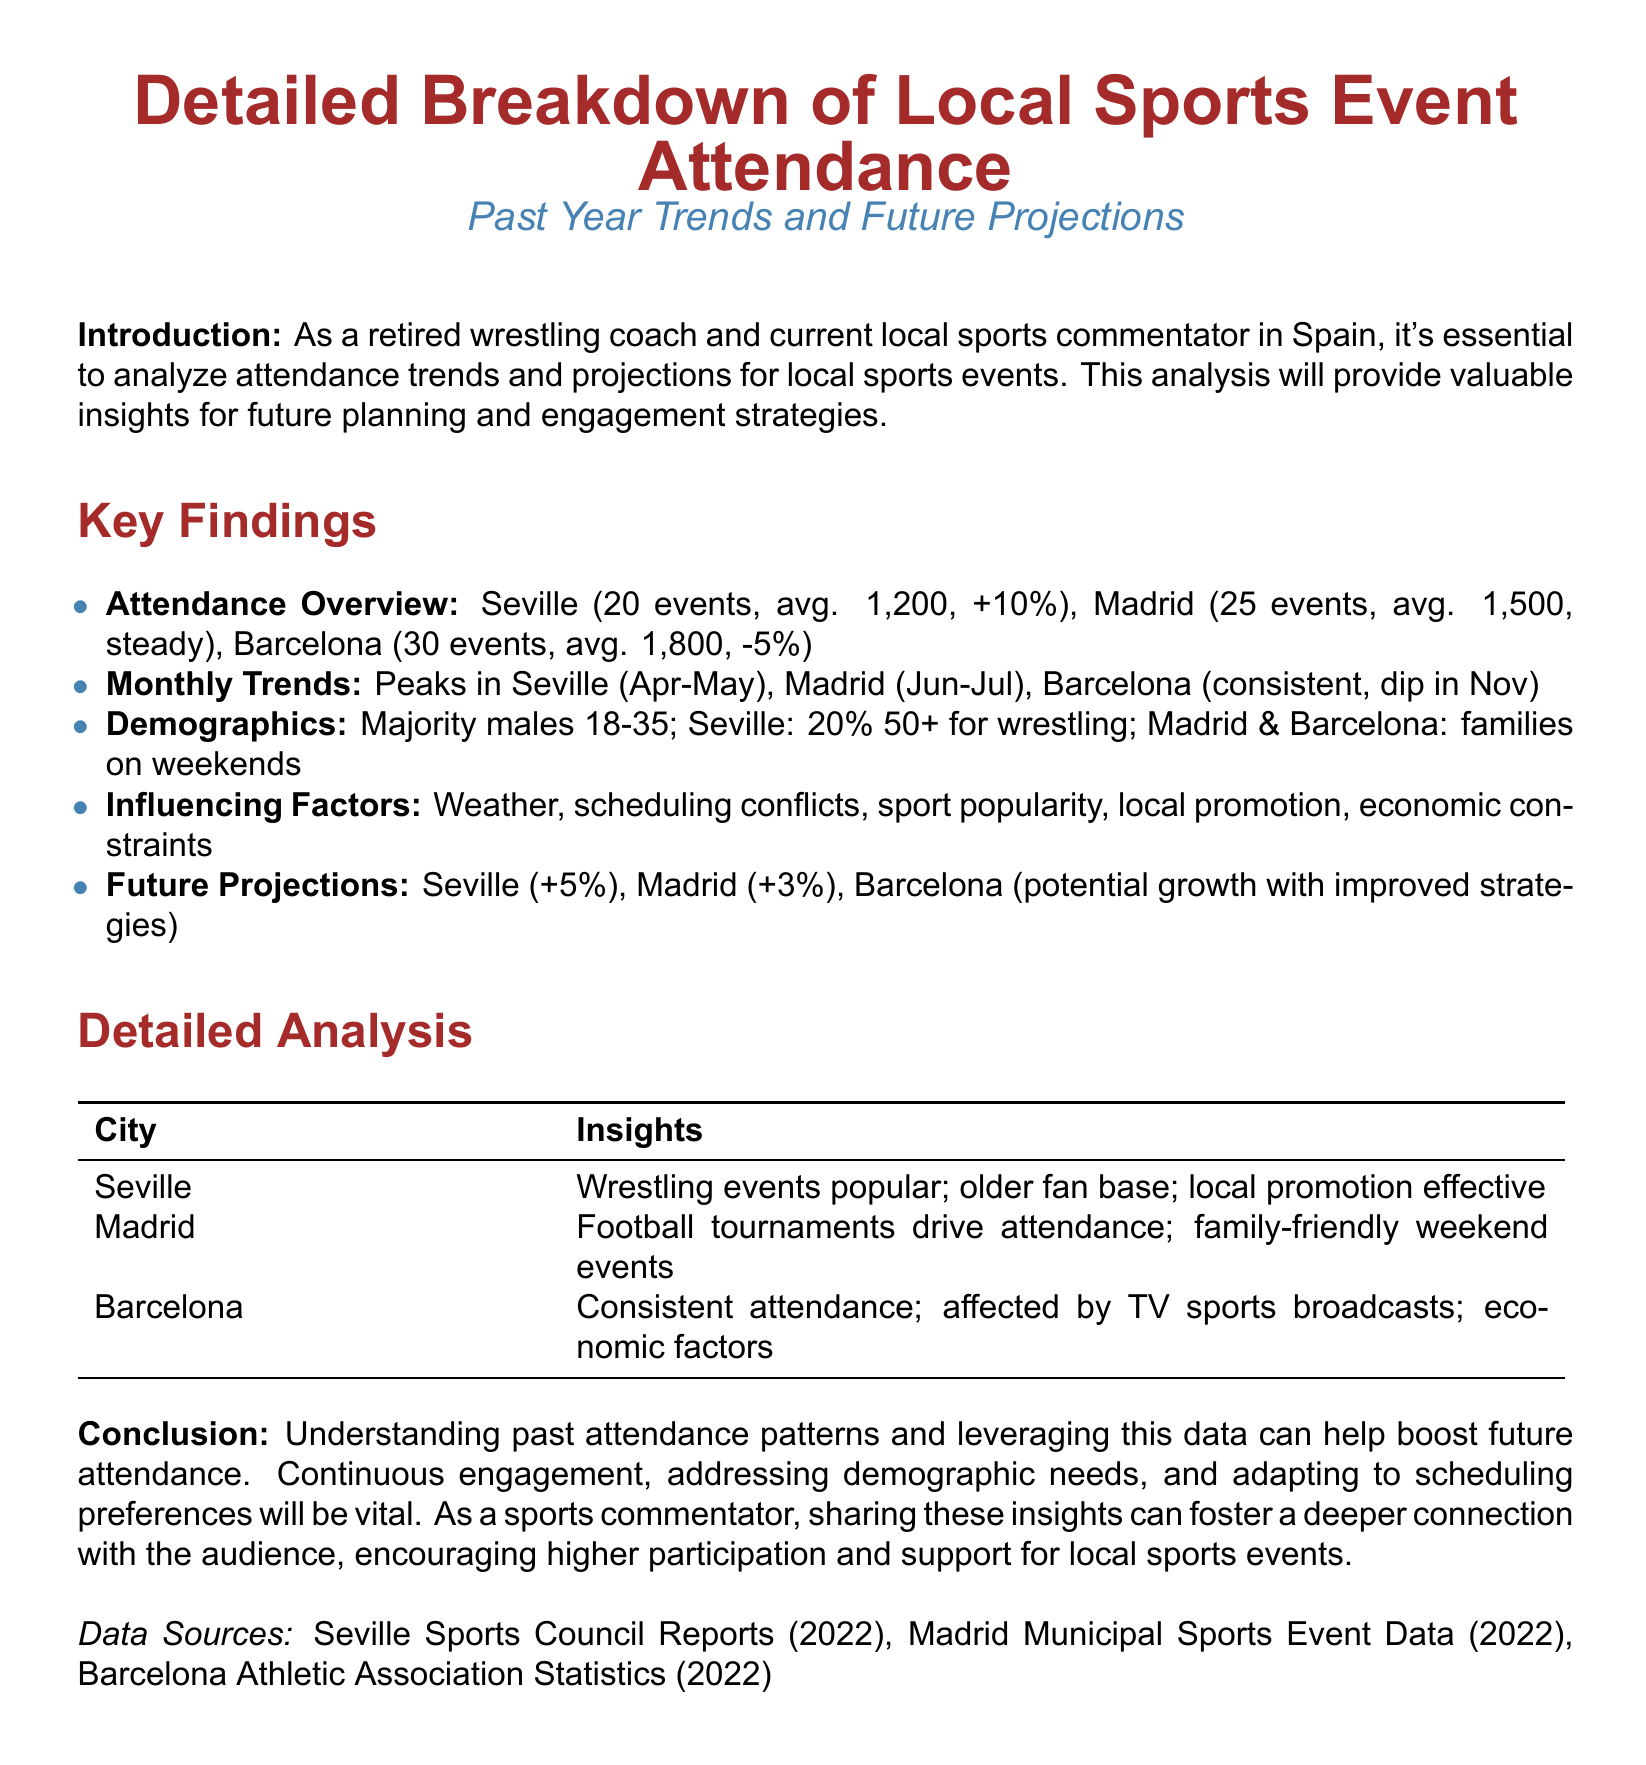What was the average attendance in Madrid? The average attendance in Madrid is mentioned in the overview section of the document, which states it as 1,500.
Answer: 1,500 How many events were held in Seville? The document specifies that there were 20 events held in Seville over the past year.
Answer: 20 What percentage increase is projected for Seville's attendance? The future projections section indicates a +5% increase for Seville's attendance.
Answer: +5% Which city experienced a dip in attendance in November? The monthly trends section mentions that Barcelona saw a dip in November.
Answer: Barcelona What is the primary demographic attending events in Seville? The document indicates that the majority attending wrestling events in Seville are males aged 18-35, with 20% being 50+.
Answer: Males 18-35 What factor is cited as influencing attendance? The document lists several factors, including weather, scheduling conflicts, sport popularity, local promotion, and economic constraints, indicating that these all influence attendance.
Answer: Weather In which months do events in Seville peak? The monthly trends indicate a peak in attendance for events in Seville during April and May.
Answer: April-May What is the average attendance in Barcelona? The document provides the average attendance for Barcelona as 1,800.
Answer: 1,800 Which sport primarily drives attendance in Madrid? The insights for Madrid highlight that football tournaments are the primary drivers of attendance.
Answer: Football 